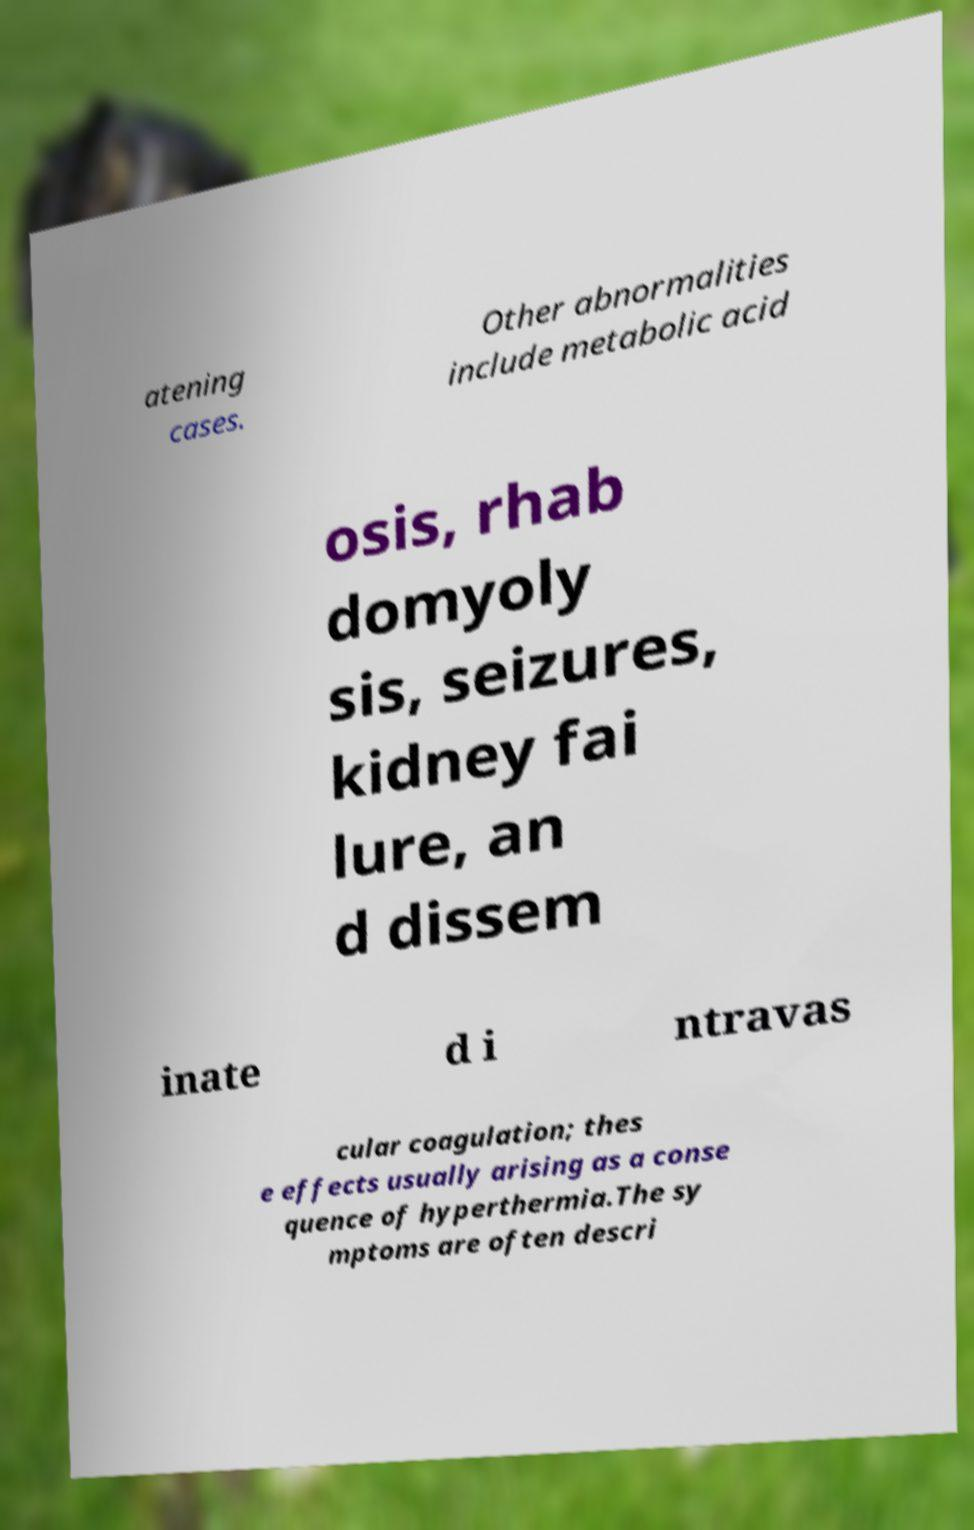There's text embedded in this image that I need extracted. Can you transcribe it verbatim? atening cases. Other abnormalities include metabolic acid osis, rhab domyoly sis, seizures, kidney fai lure, an d dissem inate d i ntravas cular coagulation; thes e effects usually arising as a conse quence of hyperthermia.The sy mptoms are often descri 